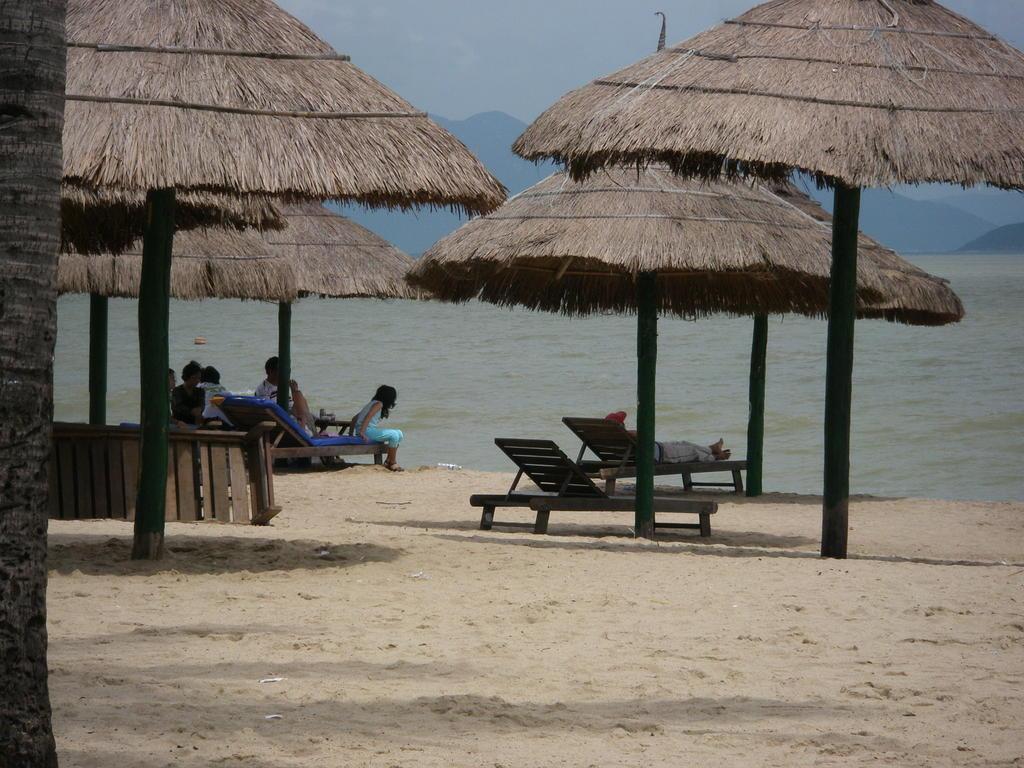Describe this image in one or two sentences. In this image, there are thatched umbrellas and I can see few people sitting on the chairs, which are on the sand. There is water. In the background, I can see the hills and the sky. 